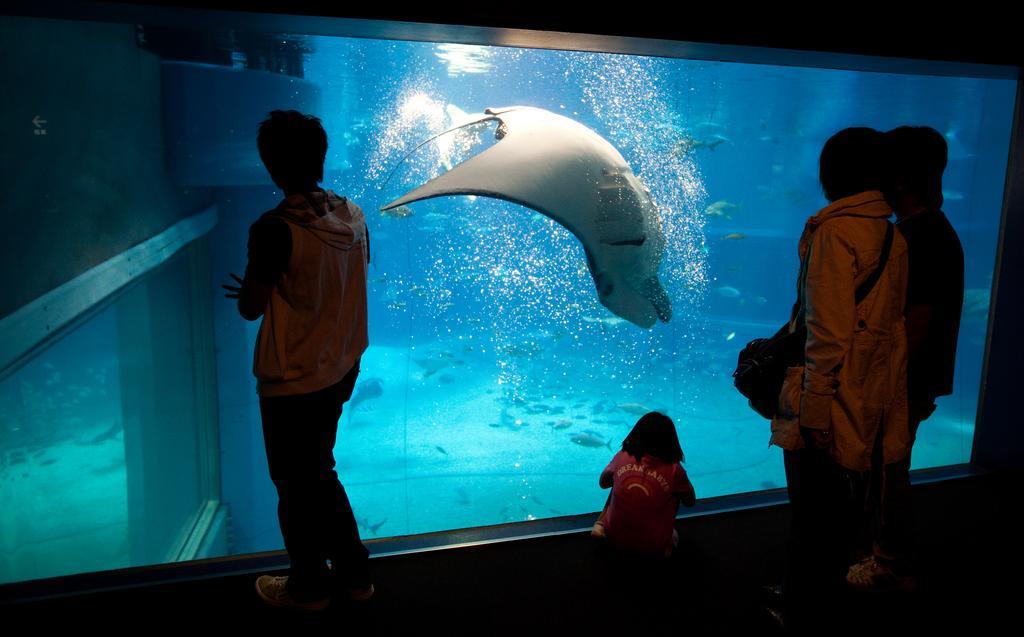In one or two sentences, can you explain what this image depicts? In the image we can see there are people standing and one is sitting, they are wearing clothes and some of them are wearing shoes and carrying bags. Here we can see the aquarium and in the aquarium, we can see there are many fishes. 